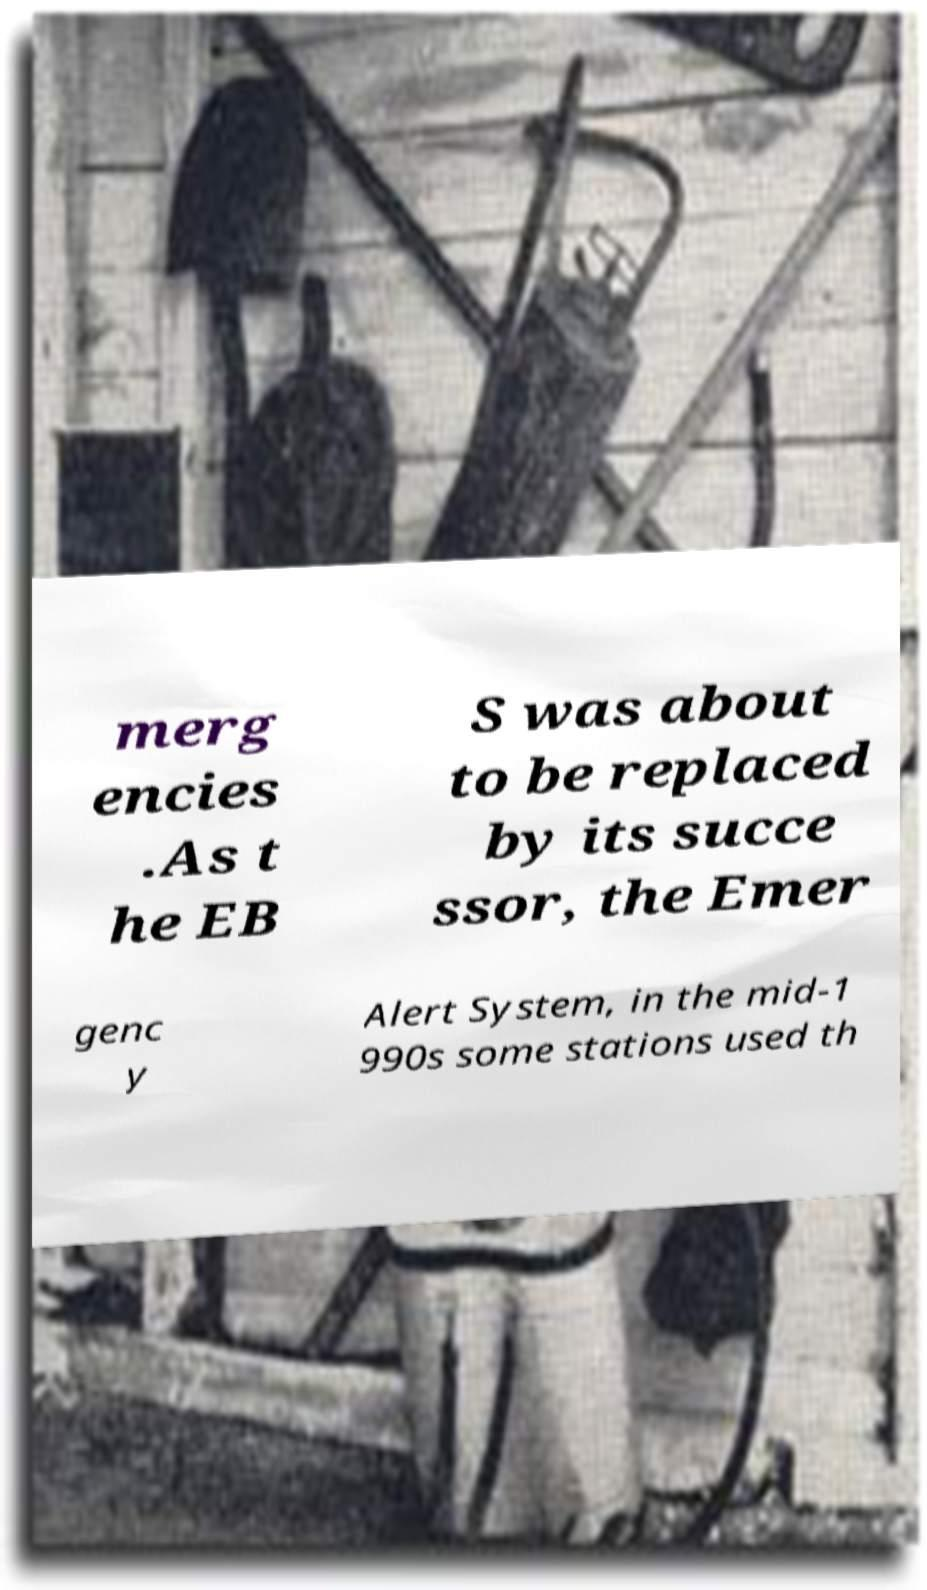What messages or text are displayed in this image? I need them in a readable, typed format. merg encies .As t he EB S was about to be replaced by its succe ssor, the Emer genc y Alert System, in the mid-1 990s some stations used th 